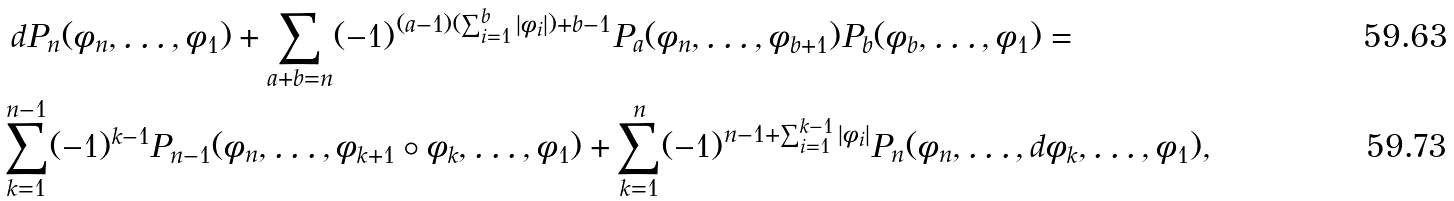<formula> <loc_0><loc_0><loc_500><loc_500>& \ d P _ { n } ( \phi _ { n } , \dots , \phi _ { 1 } ) + \sum _ { a + b = n } ( - 1 ) ^ { ( a - 1 ) ( \sum _ { i = 1 } ^ { b } | \phi _ { i } | ) + b - 1 } P _ { a } ( \phi _ { n } , \dots , \phi _ { b + 1 } ) P _ { b } ( \phi _ { b } , \dots , \phi _ { 1 } ) = \\ & \sum _ { k = 1 } ^ { n - 1 } ( - 1 ) ^ { k - 1 } P _ { n - 1 } ( \phi _ { n } , \dots , \phi _ { k + 1 } \circ \phi _ { k } , \dots , \phi _ { 1 } ) + \sum _ { k = 1 } ^ { n } ( - 1 ) ^ { n - 1 + \sum _ { i = 1 } ^ { k - 1 } | \phi _ { i } | } P _ { n } ( \phi _ { n } , \dots , d \phi _ { k } , \dots , \phi _ { 1 } ) ,</formula> 